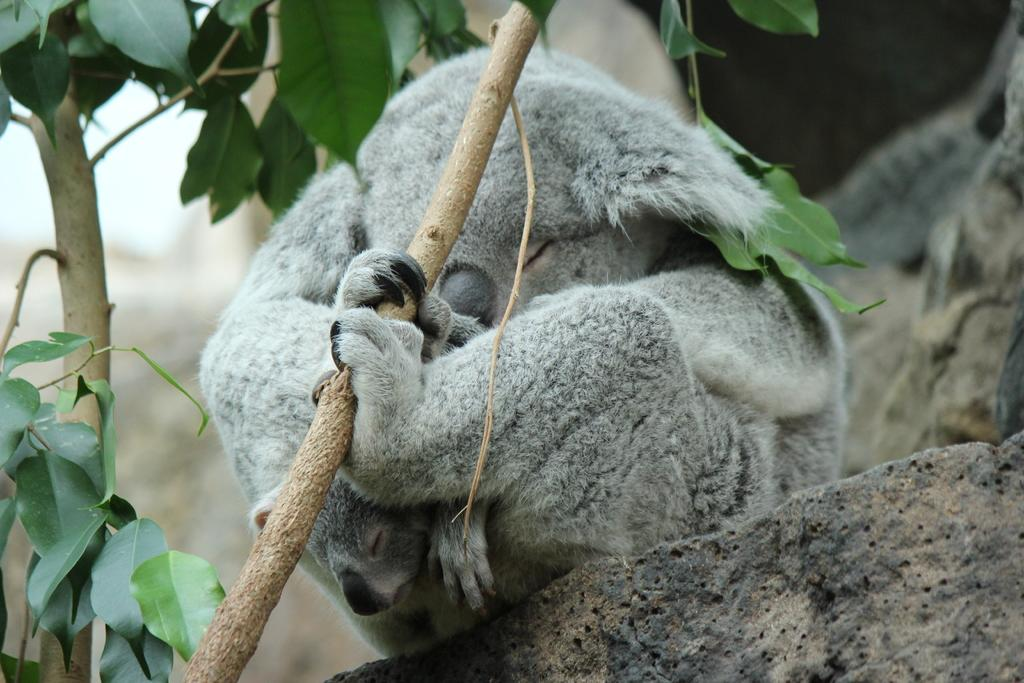What animals are present in the image? There are two panda bears in the image. Where are the pandas located? The pandas are sitting on a rock. What are the pandas holding in the image? The pandas are holding a branch of a tree. What type of cream can be seen on the bell in the image? There is no bell or cream present in the image; it features two panda bears sitting on a rock and holding a branch of a tree. 